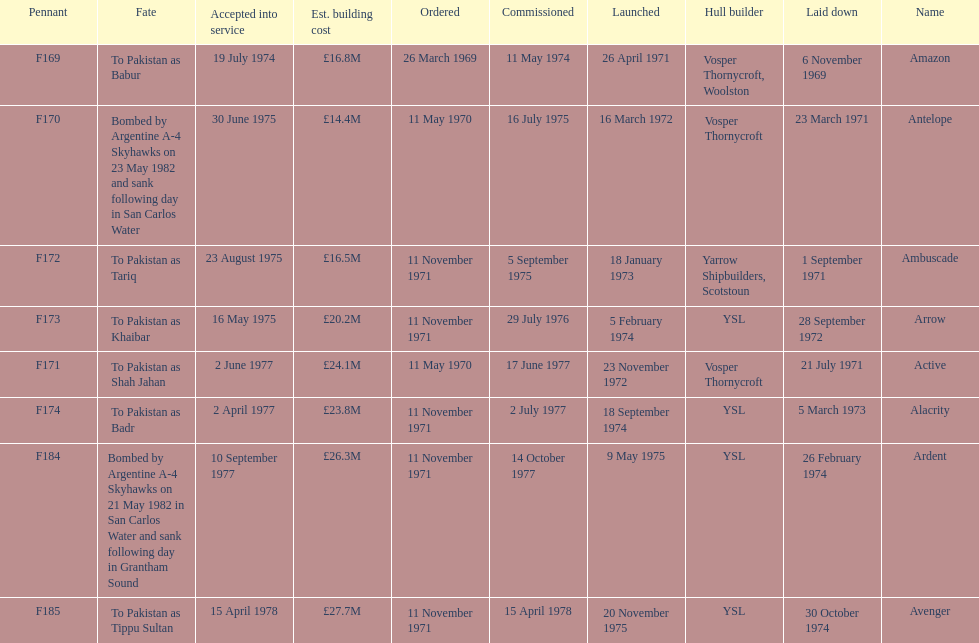Tell me the number of ships that went to pakistan. 6. I'm looking to parse the entire table for insights. Could you assist me with that? {'header': ['Pennant', 'Fate', 'Accepted into service', 'Est. building cost', 'Ordered', 'Commissioned', 'Launched', 'Hull builder', 'Laid down', 'Name'], 'rows': [['F169', 'To Pakistan as Babur', '19 July 1974', '£16.8M', '26 March 1969', '11 May 1974', '26 April 1971', 'Vosper Thornycroft, Woolston', '6 November 1969', 'Amazon'], ['F170', 'Bombed by Argentine A-4 Skyhawks on 23 May 1982 and sank following day in San Carlos Water', '30 June 1975', '£14.4M', '11 May 1970', '16 July 1975', '16 March 1972', 'Vosper Thornycroft', '23 March 1971', 'Antelope'], ['F172', 'To Pakistan as Tariq', '23 August 1975', '£16.5M', '11 November 1971', '5 September 1975', '18 January 1973', 'Yarrow Shipbuilders, Scotstoun', '1 September 1971', 'Ambuscade'], ['F173', 'To Pakistan as Khaibar', '16 May 1975', '£20.2M', '11 November 1971', '29 July 1976', '5 February 1974', 'YSL', '28 September 1972', 'Arrow'], ['F171', 'To Pakistan as Shah Jahan', '2 June 1977', '£24.1M', '11 May 1970', '17 June 1977', '23 November 1972', 'Vosper Thornycroft', '21 July 1971', 'Active'], ['F174', 'To Pakistan as Badr', '2 April 1977', '£23.8M', '11 November 1971', '2 July 1977', '18 September 1974', 'YSL', '5 March 1973', 'Alacrity'], ['F184', 'Bombed by Argentine A-4 Skyhawks on 21 May 1982 in San Carlos Water and sank following day in Grantham Sound', '10 September 1977', '£26.3M', '11 November 1971', '14 October 1977', '9 May 1975', 'YSL', '26 February 1974', 'Ardent'], ['F185', 'To Pakistan as Tippu Sultan', '15 April 1978', '£27.7M', '11 November 1971', '15 April 1978', '20 November 1975', 'YSL', '30 October 1974', 'Avenger']]} 